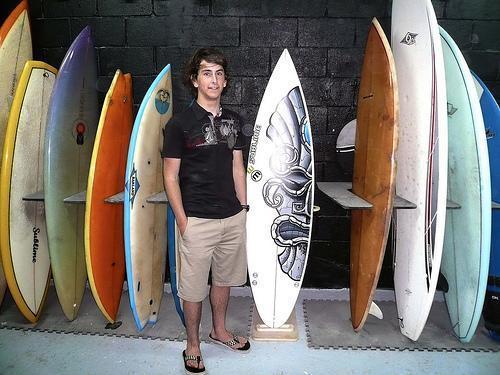How many people are in the picture?
Give a very brief answer. 1. How many suurfboards are to the left of the man?
Give a very brief answer. 5. 